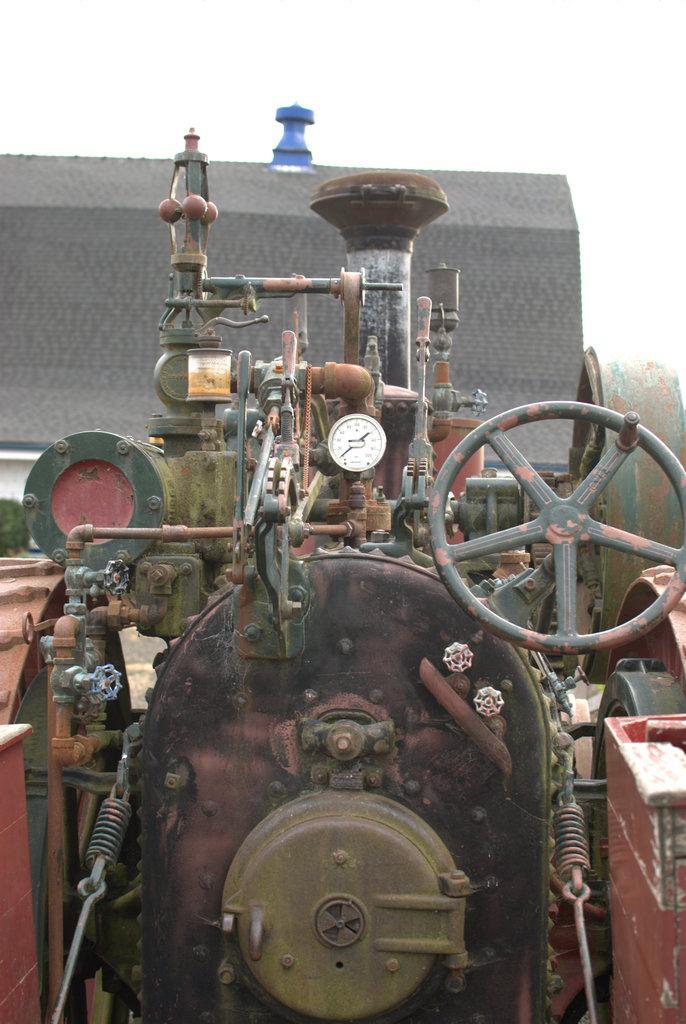Can you describe this image briefly? In this picture I can see the engine of a tractor. In the back there is a shed, beside that I can see the plants and trees. At the top there is a sky. On the right I can see the steering and speedometer. 